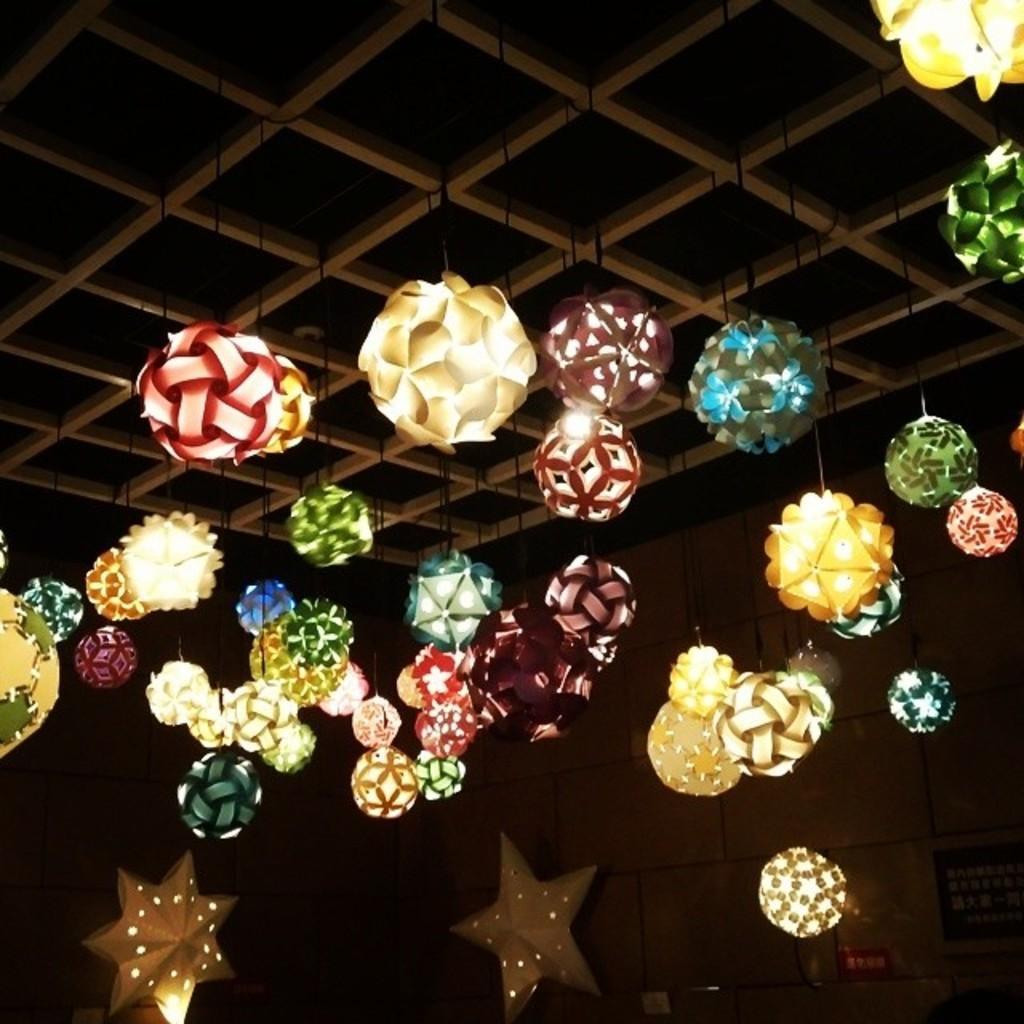Could you give a brief overview of what you see in this image? In this image there are lights. 